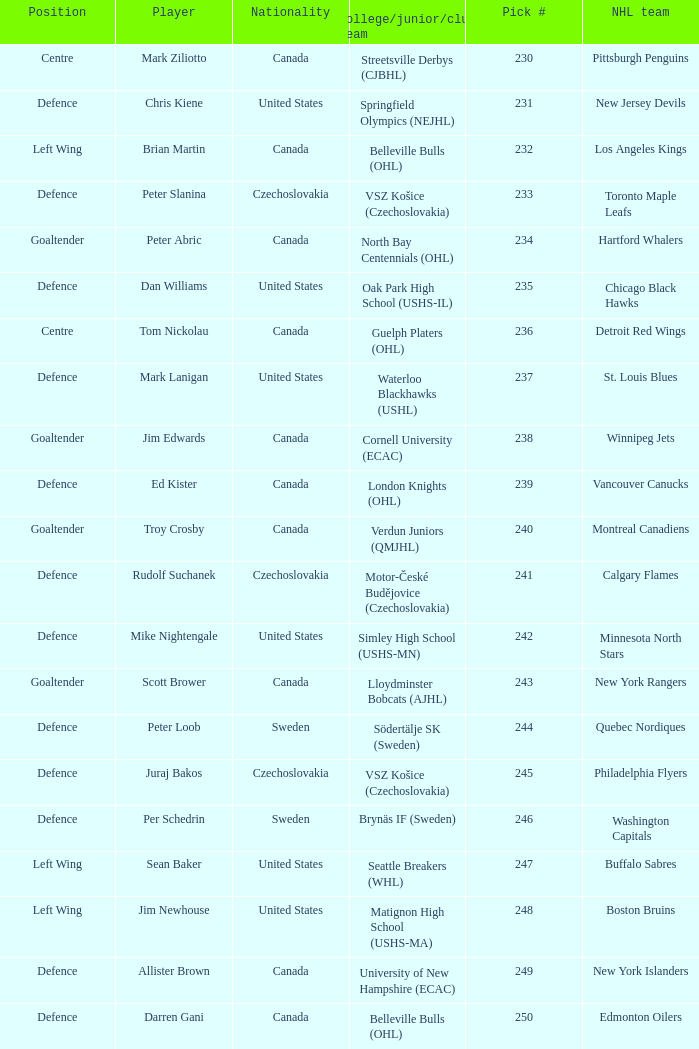To which organziation does the  winnipeg jets belong to? Cornell University (ECAC). 